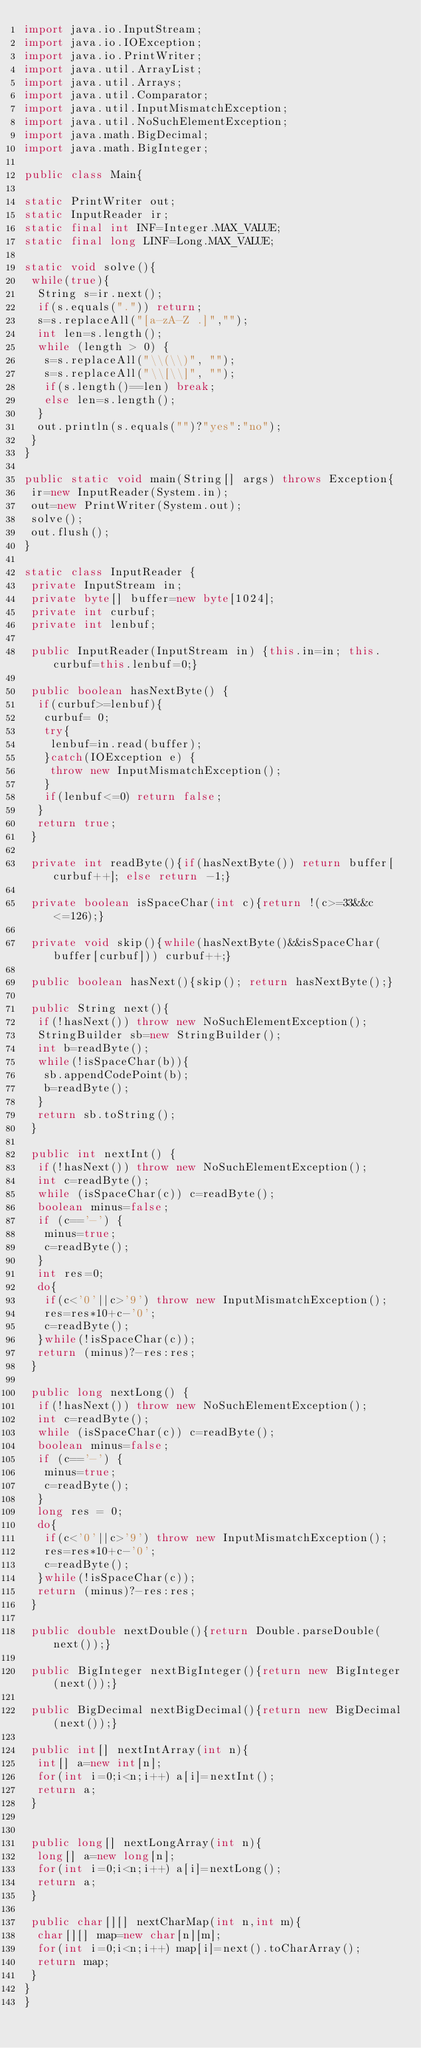<code> <loc_0><loc_0><loc_500><loc_500><_Java_>import java.io.InputStream;
import java.io.IOException;
import java.io.PrintWriter;
import java.util.ArrayList;
import java.util.Arrays;
import java.util.Comparator;
import java.util.InputMismatchException;
import java.util.NoSuchElementException;
import java.math.BigDecimal;
import java.math.BigInteger;
    
public class Main{
 
static PrintWriter out;
static InputReader ir;
static final int INF=Integer.MAX_VALUE;
static final long LINF=Long.MAX_VALUE;
 
static void solve(){
 while(true){
  String s=ir.next();
  if(s.equals(".")) return;
  s=s.replaceAll("[a-zA-Z .]","");
  int len=s.length();
  while (length > 0) {
   s=s.replaceAll("\\(\\)", "");
   s=s.replaceAll("\\[\\]", "");
   if(s.length()==len) break;
   else len=s.length();
  }
  out.println(s.equals("")?"yes":"no");
 }
}

public static void main(String[] args) throws Exception{
 ir=new InputReader(System.in);
 out=new PrintWriter(System.out);
 solve();
 out.flush();
}

static class InputReader {
 private InputStream in;
 private byte[] buffer=new byte[1024];
 private int curbuf;
 private int lenbuf;

 public InputReader(InputStream in) {this.in=in; this.curbuf=this.lenbuf=0;}
 
 public boolean hasNextByte() {
  if(curbuf>=lenbuf){
   curbuf= 0;
   try{
    lenbuf=in.read(buffer);
   }catch(IOException e) {
    throw new InputMismatchException();
   }
   if(lenbuf<=0) return false;
  }
  return true;
 }

 private int readByte(){if(hasNextByte()) return buffer[curbuf++]; else return -1;}
 
 private boolean isSpaceChar(int c){return !(c>=33&&c<=126);}
 
 private void skip(){while(hasNextByte()&&isSpaceChar(buffer[curbuf])) curbuf++;}
 
 public boolean hasNext(){skip(); return hasNextByte();}
 
 public String next(){
  if(!hasNext()) throw new NoSuchElementException();
  StringBuilder sb=new StringBuilder();
  int b=readByte();
  while(!isSpaceChar(b)){
   sb.appendCodePoint(b);
   b=readByte();
  }
  return sb.toString();
 }
 
 public int nextInt() {
  if(!hasNext()) throw new NoSuchElementException();
  int c=readByte();
  while (isSpaceChar(c)) c=readByte();
  boolean minus=false;
  if (c=='-') {
   minus=true;
   c=readByte();
  }
  int res=0;
  do{
   if(c<'0'||c>'9') throw new InputMismatchException();
   res=res*10+c-'0';
   c=readByte();
  }while(!isSpaceChar(c));
  return (minus)?-res:res;
 }
 
 public long nextLong() {
  if(!hasNext()) throw new NoSuchElementException();
  int c=readByte();
  while (isSpaceChar(c)) c=readByte();
  boolean minus=false;
  if (c=='-') {
   minus=true;
   c=readByte();
  }
  long res = 0;
  do{
   if(c<'0'||c>'9') throw new InputMismatchException();
   res=res*10+c-'0';
   c=readByte();
  }while(!isSpaceChar(c));
  return (minus)?-res:res;
 }
 
 public double nextDouble(){return Double.parseDouble(next());}
 
 public BigInteger nextBigInteger(){return new BigInteger(next());}
 
 public BigDecimal nextBigDecimal(){return new BigDecimal(next());}
 
 public int[] nextIntArray(int n){
  int[] a=new int[n];
  for(int i=0;i<n;i++) a[i]=nextInt();
  return a;
 }
 
 
 public long[] nextLongArray(int n){
  long[] a=new long[n];
  for(int i=0;i<n;i++) a[i]=nextLong();
  return a;
 }

 public char[][] nextCharMap(int n,int m){
  char[][] map=new char[n][m];
  for(int i=0;i<n;i++) map[i]=next().toCharArray();
  return map;
 }
}
}</code> 